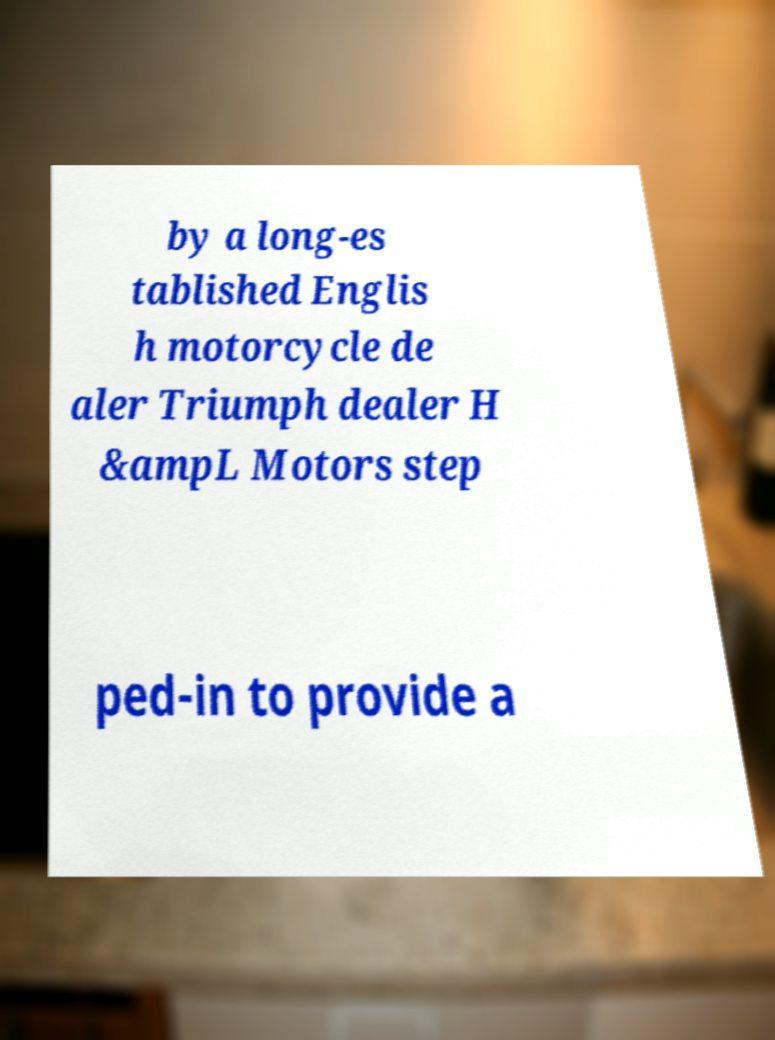I need the written content from this picture converted into text. Can you do that? by a long-es tablished Englis h motorcycle de aler Triumph dealer H &ampL Motors step ped-in to provide a 